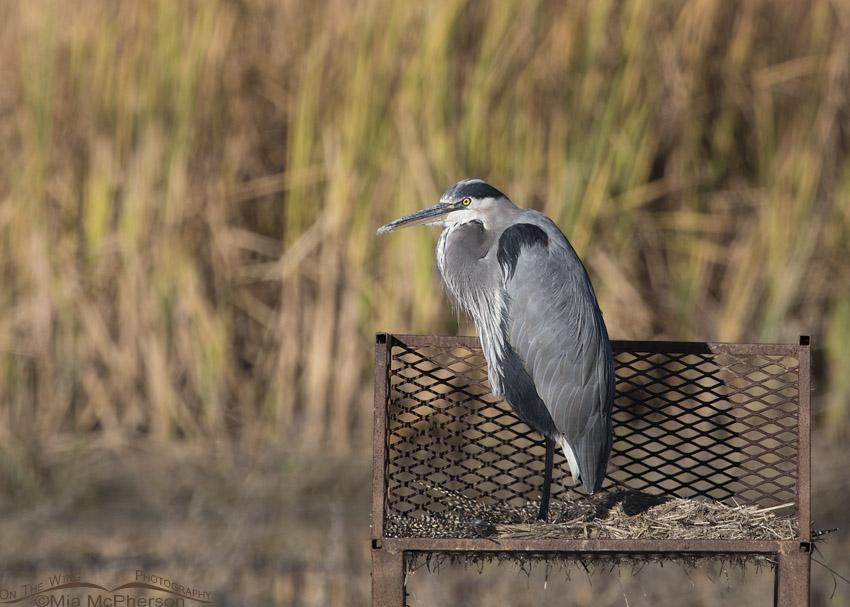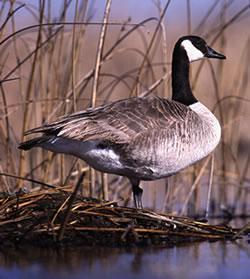The first image is the image on the left, the second image is the image on the right. Given the left and right images, does the statement "4 geese total with two having heads tucked in their feathers" hold true? Answer yes or no. No. The first image is the image on the left, the second image is the image on the right. Evaluate the accuracy of this statement regarding the images: "An image shows one bird in the water, with its neck turned backward.". Is it true? Answer yes or no. No. 